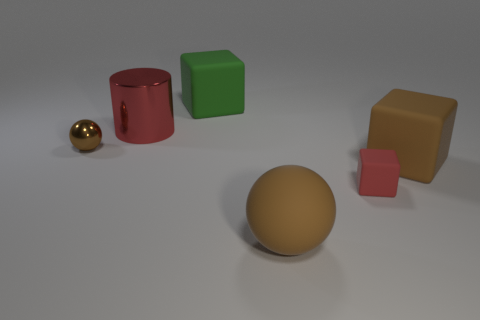There is a sphere that is to the right of the green cube; is it the same color as the matte object that is behind the big metal cylinder?
Offer a terse response. No. There is a object that is both in front of the green thing and behind the brown metal object; what is its shape?
Provide a short and direct response. Cylinder. The sphere that is the same size as the red shiny cylinder is what color?
Offer a very short reply. Brown. Is there a big shiny ball of the same color as the tiny metal ball?
Provide a succinct answer. No. Do the red object on the left side of the big green rubber object and the brown cube in front of the large red thing have the same size?
Ensure brevity in your answer.  Yes. There is a object that is both right of the big metal thing and behind the small shiny ball; what material is it made of?
Give a very brief answer. Rubber. The other thing that is the same color as the tiny rubber thing is what size?
Your answer should be compact. Large. How many other objects are the same size as the metal cylinder?
Make the answer very short. 3. There is a cube that is to the left of the brown matte ball; what material is it?
Offer a terse response. Rubber. Do the green thing and the red rubber object have the same shape?
Offer a very short reply. Yes. 